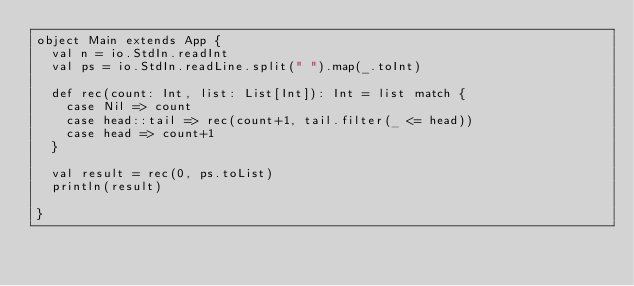Convert code to text. <code><loc_0><loc_0><loc_500><loc_500><_Scala_>object Main extends App {
  val n = io.StdIn.readInt
  val ps = io.StdIn.readLine.split(" ").map(_.toInt)

  def rec(count: Int, list: List[Int]): Int = list match {
    case Nil => count
    case head::tail => rec(count+1, tail.filter(_ <= head))
    case head => count+1
  }

  val result = rec(0, ps.toList)
  println(result)
        
}</code> 